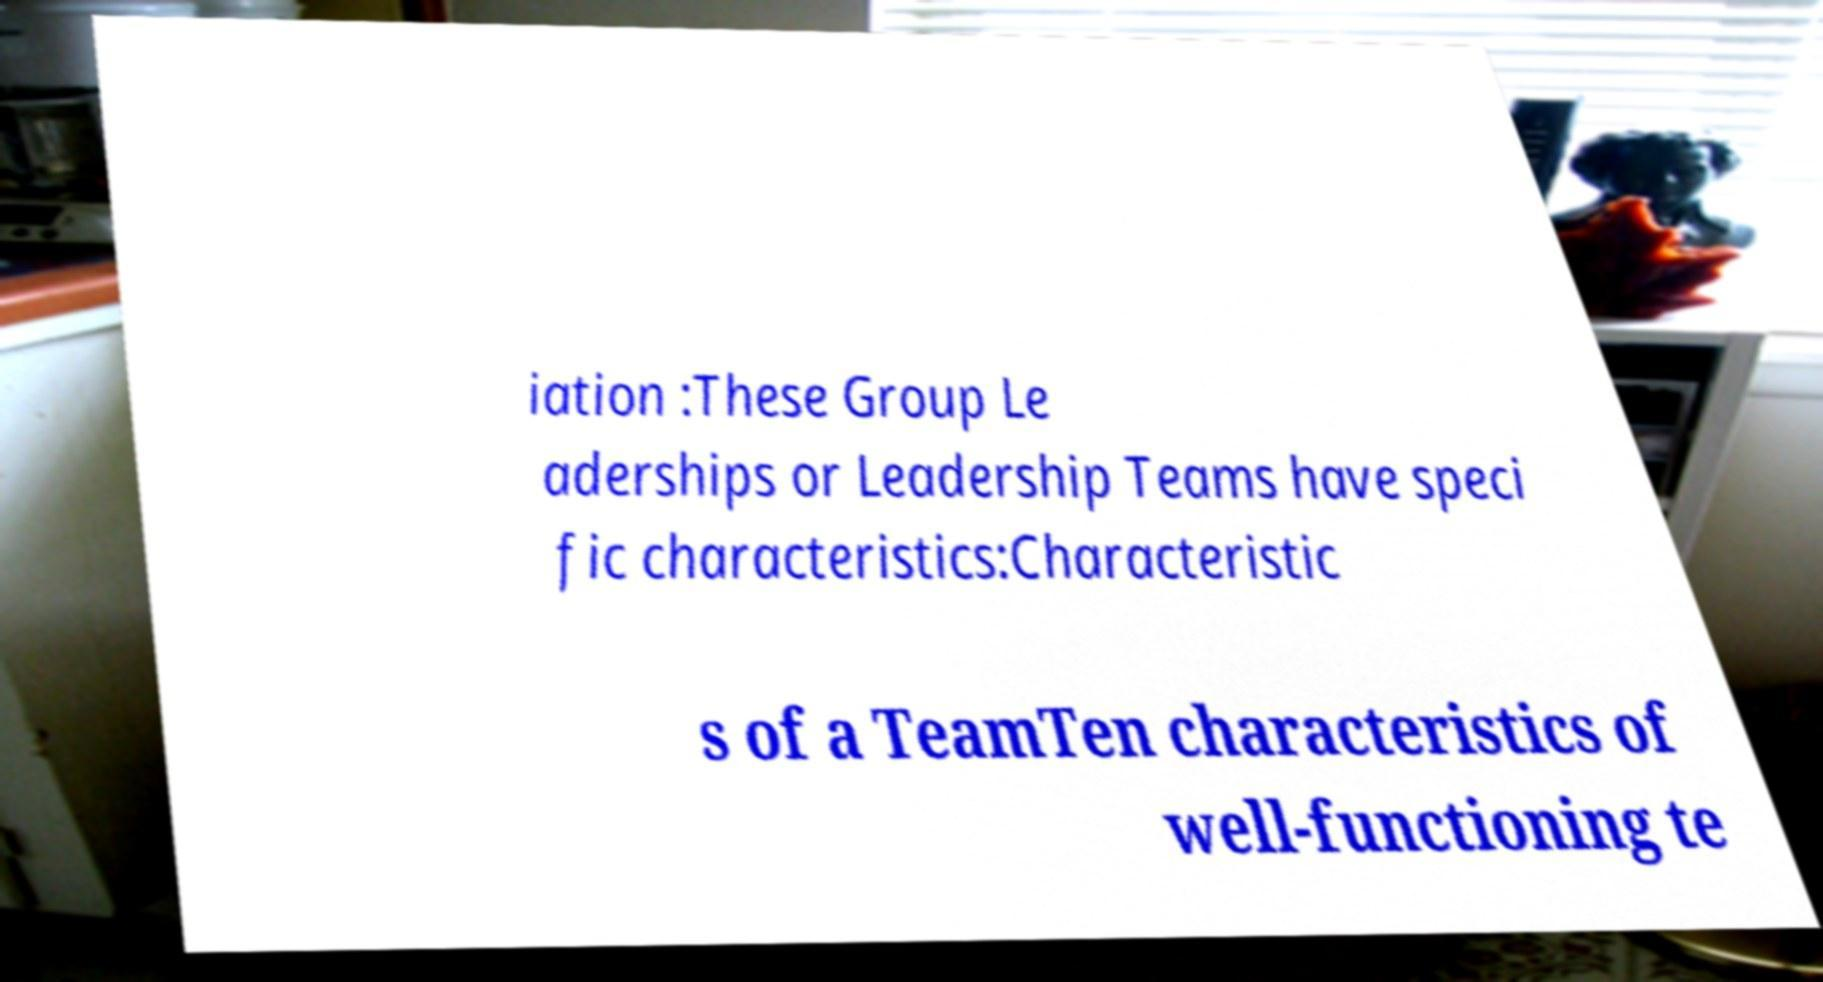Please read and relay the text visible in this image. What does it say? iation :These Group Le aderships or Leadership Teams have speci fic characteristics:Characteristic s of a TeamTen characteristics of well-functioning te 